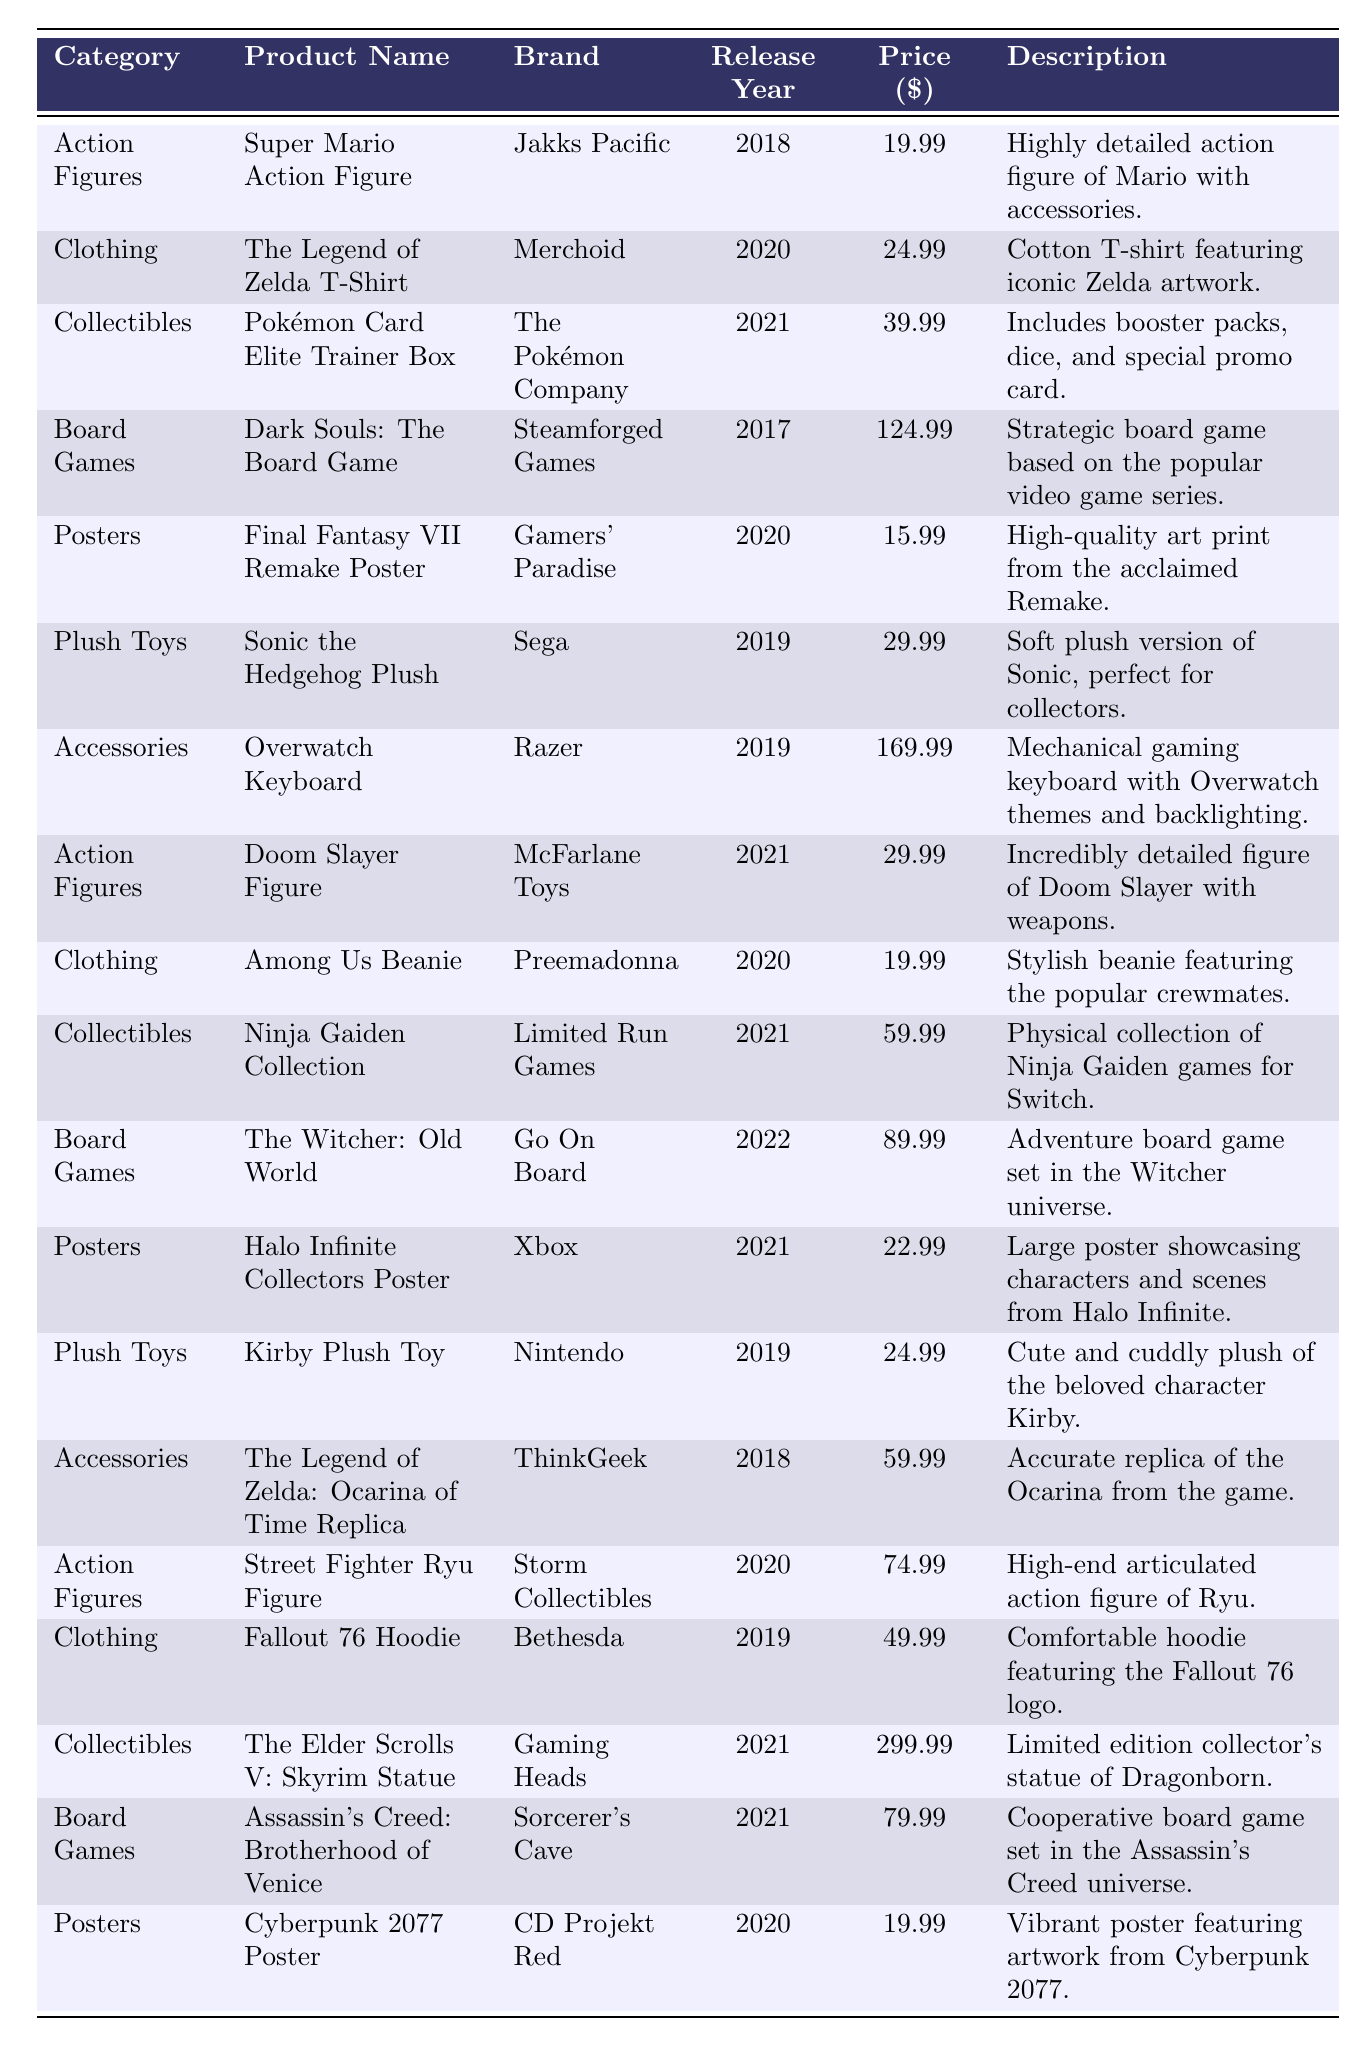What is the price of the Kirby Plush Toy? The table lists the Kirby Plush Toy under the Plush Toys category, and the Price column shows that it is $24.99.
Answer: 24.99 Which category has the most expensive product listed? By comparing the prices in the table, The Elder Scrolls V: Skyrim Statue in the Collectibles category has the highest price at $299.99.
Answer: Collectibles How many clothing items are listed in the table? The table includes three clothing items: The Legend of Zelda T-Shirt, Among Us Beanie, and Fallout 76 Hoodie. Thus, the count is 3.
Answer: 3 What is the total cost of all Board Games listed? The prices for Board Games are Dark Souls: The Board Game ($124.99), The Witcher: Old World ($89.99), and Assassin's Creed: Brotherhood of Venice ($79.99). Summing these gives $124.99 + $89.99 + $79.99 = $294.97.
Answer: 294.97 Is there a video game-themed product released in 2018? Yes, both the Super Mario Action Figure and The Legend of Zelda: Ocarina of Time Replica were released in 2018, confirming the existence of such products.
Answer: Yes What is the average price of all Collectibles? The prices for Collectibles are Pokémon Card Elite Trainer Box ($39.99), Ninja Gaiden Collection ($59.99), and The Elder Scrolls V: Skyrim Statue ($299.99). The total is $39.99 + $59.99 + $299.99 = $399.97 and there are 3 items. Thus, the average price is $399.97 / 3 = $133.32.
Answer: 133.32 What product features Sonic and what is its price? The item featuring Sonic is the Sonic the Hedgehog Plush, which is listed with a price of $29.99.
Answer: Sonic the Hedgehog Plush, 29.99 How many action figures are priced above $50? The action figures in the table are Super Mario Action Figure ($19.99), Doom Slayer Figure ($29.99), and Street Fighter Ryu Figure ($74.99). Only the Street Fighter Ryu Figure exceeds $50, indicating just 1 action figure falls into that category.
Answer: 1 Which brand has the most products represented in the table? By reviewing the table, we see several brands: Jakks Pacific (1), Merchoid (1), The Pokémon Company (1), Steamforged Games (1), Gamers' Paradise (1), Sega (1), Razer (1), McFarlane Toys (1), Preemadonna (1), Limited Run Games (1), Go On Board (1), Xbox (1), Nintendo (1), ThinkGeek (1), Storm Collectibles (1), Bethesda (1), Gaming Heads (1), and Sorcerer's Cave (1) — all have a count of 1, thus no single brand has more than 1 product featured.
Answer: None What was the release year of the Overwatch Keyboard? The table shows that the Overwatch Keyboard by Razer was released in 2019.
Answer: 2019 